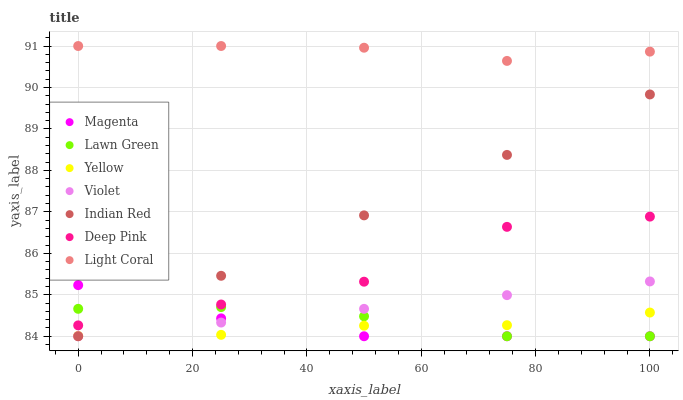Does Yellow have the minimum area under the curve?
Answer yes or no. Yes. Does Light Coral have the maximum area under the curve?
Answer yes or no. Yes. Does Deep Pink have the minimum area under the curve?
Answer yes or no. No. Does Deep Pink have the maximum area under the curve?
Answer yes or no. No. Is Violet the smoothest?
Answer yes or no. Yes. Is Deep Pink the roughest?
Answer yes or no. Yes. Is Yellow the smoothest?
Answer yes or no. No. Is Yellow the roughest?
Answer yes or no. No. Does Lawn Green have the lowest value?
Answer yes or no. Yes. Does Deep Pink have the lowest value?
Answer yes or no. No. Does Light Coral have the highest value?
Answer yes or no. Yes. Does Deep Pink have the highest value?
Answer yes or no. No. Is Indian Red less than Light Coral?
Answer yes or no. Yes. Is Light Coral greater than Indian Red?
Answer yes or no. Yes. Does Lawn Green intersect Deep Pink?
Answer yes or no. Yes. Is Lawn Green less than Deep Pink?
Answer yes or no. No. Is Lawn Green greater than Deep Pink?
Answer yes or no. No. Does Indian Red intersect Light Coral?
Answer yes or no. No. 